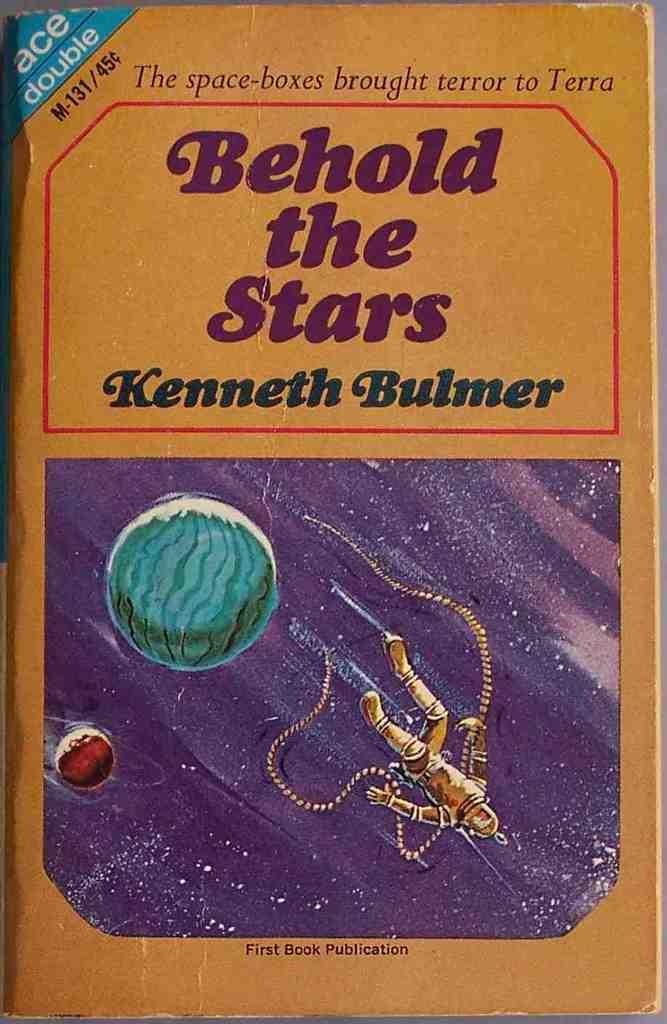What is the title of the book?
Make the answer very short. Behold the stars. 